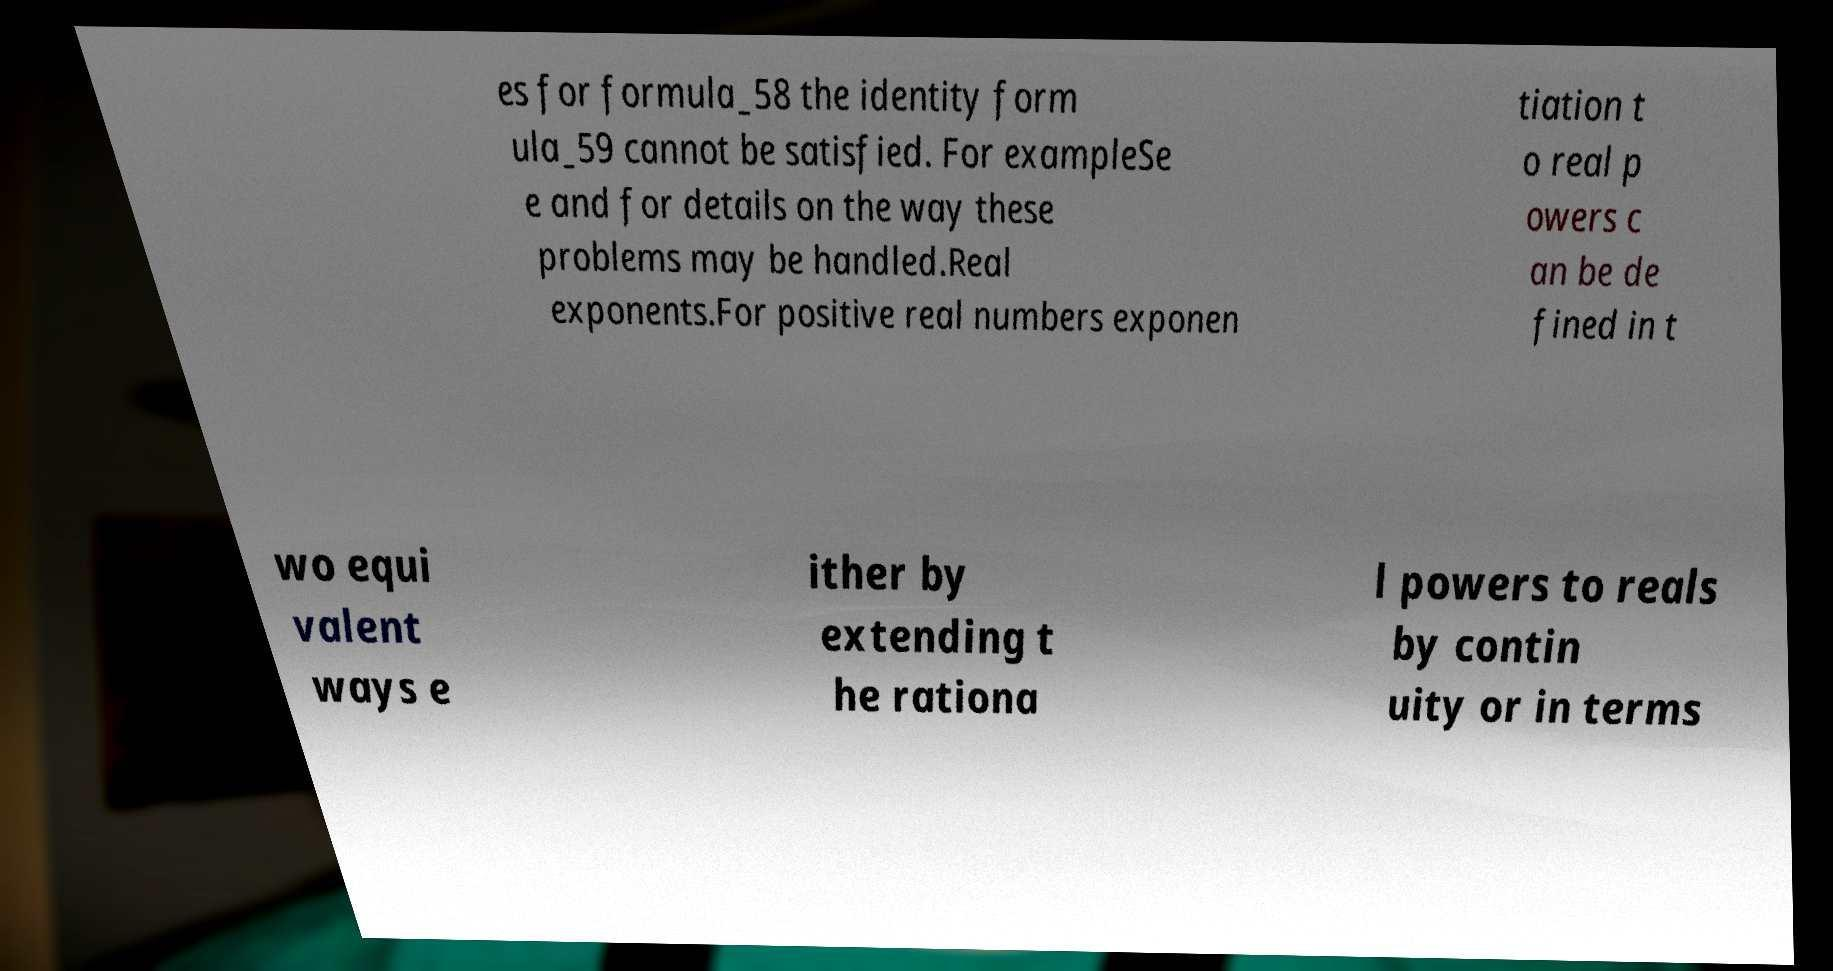What messages or text are displayed in this image? I need them in a readable, typed format. es for formula_58 the identity form ula_59 cannot be satisfied. For exampleSe e and for details on the way these problems may be handled.Real exponents.For positive real numbers exponen tiation t o real p owers c an be de fined in t wo equi valent ways e ither by extending t he rationa l powers to reals by contin uity or in terms 